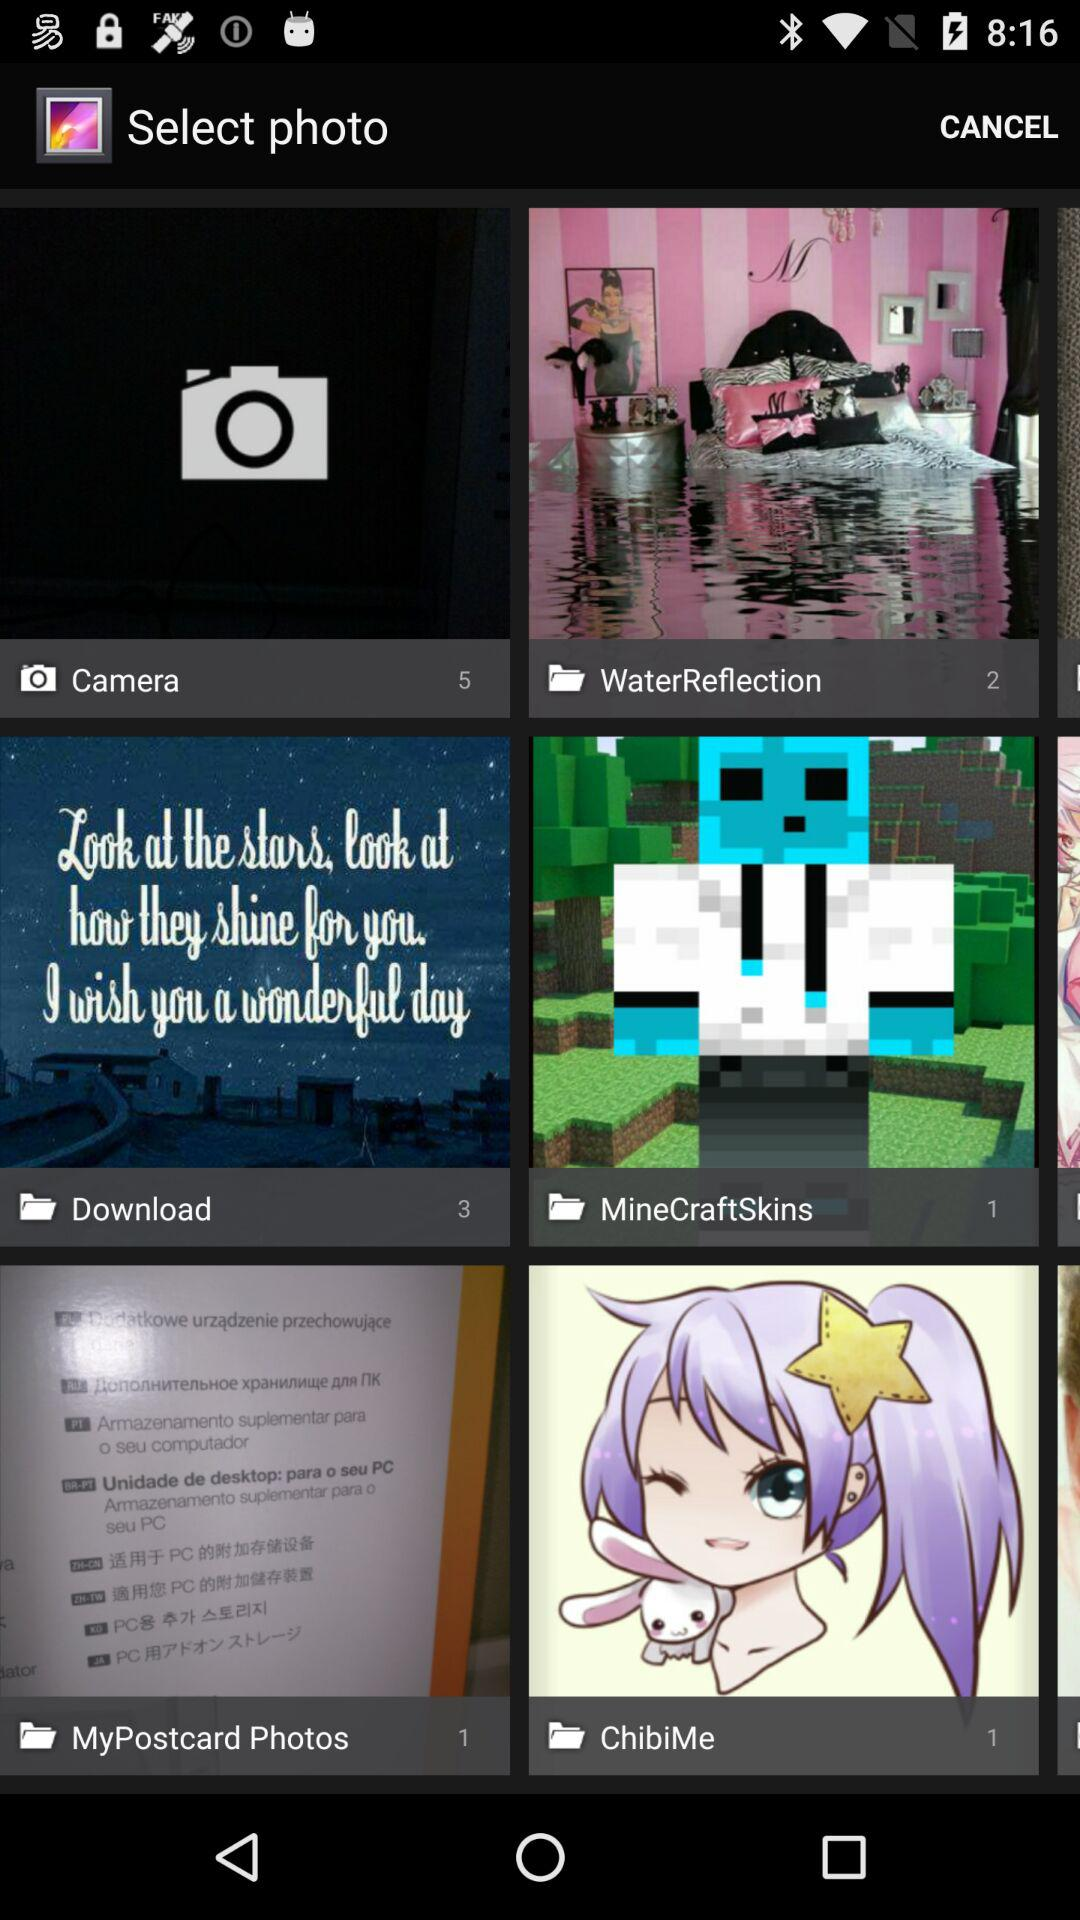What total number of images are there in the "Download" folder? The total number of images is 3. 